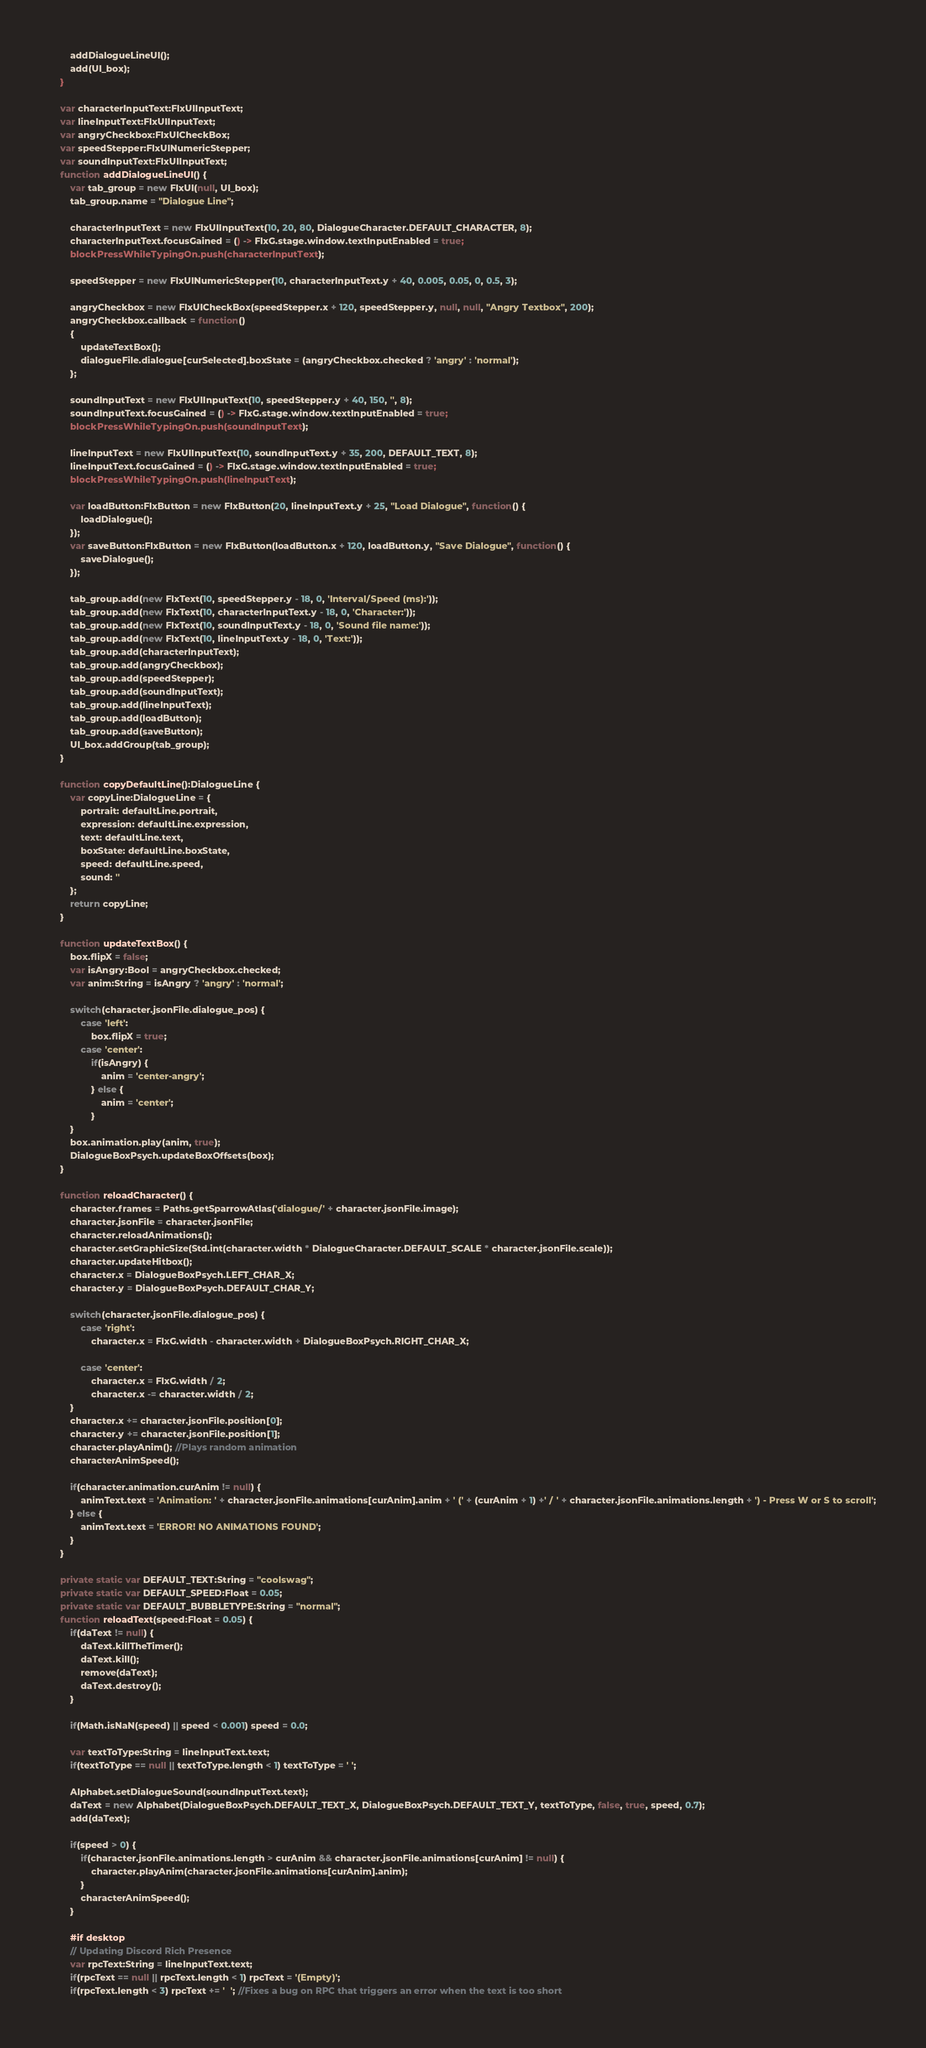<code> <loc_0><loc_0><loc_500><loc_500><_Haxe_>		addDialogueLineUI();
		add(UI_box);
	}

	var characterInputText:FlxUIInputText;
	var lineInputText:FlxUIInputText;
	var angryCheckbox:FlxUICheckBox;
	var speedStepper:FlxUINumericStepper;
	var soundInputText:FlxUIInputText;
	function addDialogueLineUI() {
		var tab_group = new FlxUI(null, UI_box);
		tab_group.name = "Dialogue Line";

		characterInputText = new FlxUIInputText(10, 20, 80, DialogueCharacter.DEFAULT_CHARACTER, 8);
		characterInputText.focusGained = () -> FlxG.stage.window.textInputEnabled = true;
		blockPressWhileTypingOn.push(characterInputText);

		speedStepper = new FlxUINumericStepper(10, characterInputText.y + 40, 0.005, 0.05, 0, 0.5, 3);

		angryCheckbox = new FlxUICheckBox(speedStepper.x + 120, speedStepper.y, null, null, "Angry Textbox", 200);
		angryCheckbox.callback = function()
		{
			updateTextBox();
			dialogueFile.dialogue[curSelected].boxState = (angryCheckbox.checked ? 'angry' : 'normal');
		};

		soundInputText = new FlxUIInputText(10, speedStepper.y + 40, 150, '', 8);
		soundInputText.focusGained = () -> FlxG.stage.window.textInputEnabled = true;
		blockPressWhileTypingOn.push(soundInputText);
		
		lineInputText = new FlxUIInputText(10, soundInputText.y + 35, 200, DEFAULT_TEXT, 8);
		lineInputText.focusGained = () -> FlxG.stage.window.textInputEnabled = true;
		blockPressWhileTypingOn.push(lineInputText);

		var loadButton:FlxButton = new FlxButton(20, lineInputText.y + 25, "Load Dialogue", function() {
			loadDialogue();
		});
		var saveButton:FlxButton = new FlxButton(loadButton.x + 120, loadButton.y, "Save Dialogue", function() {
			saveDialogue();
		});

		tab_group.add(new FlxText(10, speedStepper.y - 18, 0, 'Interval/Speed (ms):'));
		tab_group.add(new FlxText(10, characterInputText.y - 18, 0, 'Character:'));
		tab_group.add(new FlxText(10, soundInputText.y - 18, 0, 'Sound file name:'));
		tab_group.add(new FlxText(10, lineInputText.y - 18, 0, 'Text:'));
		tab_group.add(characterInputText);
		tab_group.add(angryCheckbox);
		tab_group.add(speedStepper);
		tab_group.add(soundInputText);
		tab_group.add(lineInputText);
		tab_group.add(loadButton);
		tab_group.add(saveButton);
		UI_box.addGroup(tab_group);
	}

	function copyDefaultLine():DialogueLine {
		var copyLine:DialogueLine = {
			portrait: defaultLine.portrait,
			expression: defaultLine.expression,
			text: defaultLine.text,
			boxState: defaultLine.boxState,
			speed: defaultLine.speed,
			sound: ''
		};
		return copyLine;
	}

	function updateTextBox() {
		box.flipX = false;
		var isAngry:Bool = angryCheckbox.checked;
		var anim:String = isAngry ? 'angry' : 'normal';

		switch(character.jsonFile.dialogue_pos) {
			case 'left':
				box.flipX = true;
			case 'center':
				if(isAngry) {
					anim = 'center-angry';
				} else {
					anim = 'center';
				}
		}
		box.animation.play(anim, true);
		DialogueBoxPsych.updateBoxOffsets(box);
	}

	function reloadCharacter() {
		character.frames = Paths.getSparrowAtlas('dialogue/' + character.jsonFile.image);
		character.jsonFile = character.jsonFile;
		character.reloadAnimations();
		character.setGraphicSize(Std.int(character.width * DialogueCharacter.DEFAULT_SCALE * character.jsonFile.scale));
		character.updateHitbox();
		character.x = DialogueBoxPsych.LEFT_CHAR_X;
		character.y = DialogueBoxPsych.DEFAULT_CHAR_Y;

		switch(character.jsonFile.dialogue_pos) {
			case 'right':
				character.x = FlxG.width - character.width + DialogueBoxPsych.RIGHT_CHAR_X;
			
			case 'center':
				character.x = FlxG.width / 2;
				character.x -= character.width / 2;
		}
		character.x += character.jsonFile.position[0];
		character.y += character.jsonFile.position[1];
		character.playAnim(); //Plays random animation
		characterAnimSpeed();

		if(character.animation.curAnim != null) {
			animText.text = 'Animation: ' + character.jsonFile.animations[curAnim].anim + ' (' + (curAnim + 1) +' / ' + character.jsonFile.animations.length + ') - Press W or S to scroll';
		} else {
			animText.text = 'ERROR! NO ANIMATIONS FOUND';
		}
	}

	private static var DEFAULT_TEXT:String = "coolswag";
	private static var DEFAULT_SPEED:Float = 0.05;
	private static var DEFAULT_BUBBLETYPE:String = "normal";
	function reloadText(speed:Float = 0.05) {
		if(daText != null) {
			daText.killTheTimer();
			daText.kill();
			remove(daText);
			daText.destroy();
		}

		if(Math.isNaN(speed) || speed < 0.001) speed = 0.0;

		var textToType:String = lineInputText.text;
		if(textToType == null || textToType.length < 1) textToType = ' ';
	
		Alphabet.setDialogueSound(soundInputText.text);
		daText = new Alphabet(DialogueBoxPsych.DEFAULT_TEXT_X, DialogueBoxPsych.DEFAULT_TEXT_Y, textToType, false, true, speed, 0.7);
		add(daText);

		if(speed > 0) {
			if(character.jsonFile.animations.length > curAnim && character.jsonFile.animations[curAnim] != null) {
				character.playAnim(character.jsonFile.animations[curAnim].anim);
			}
			characterAnimSpeed();
		}

		#if desktop
		// Updating Discord Rich Presence
		var rpcText:String = lineInputText.text;
		if(rpcText == null || rpcText.length < 1) rpcText = '(Empty)';
		if(rpcText.length < 3) rpcText += '  '; //Fixes a bug on RPC that triggers an error when the text is too short</code> 